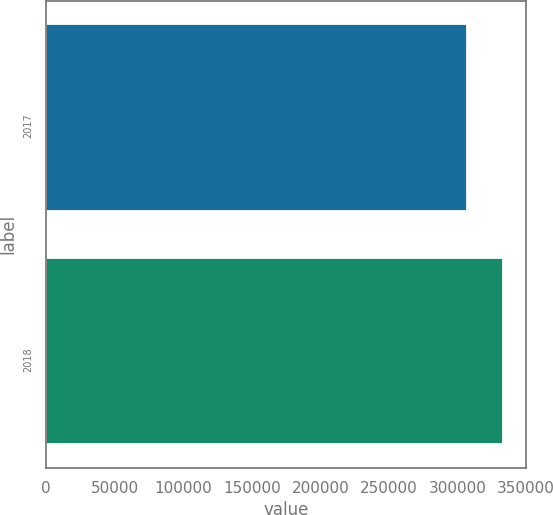Convert chart. <chart><loc_0><loc_0><loc_500><loc_500><bar_chart><fcel>2017<fcel>2018<nl><fcel>307249<fcel>333341<nl></chart> 